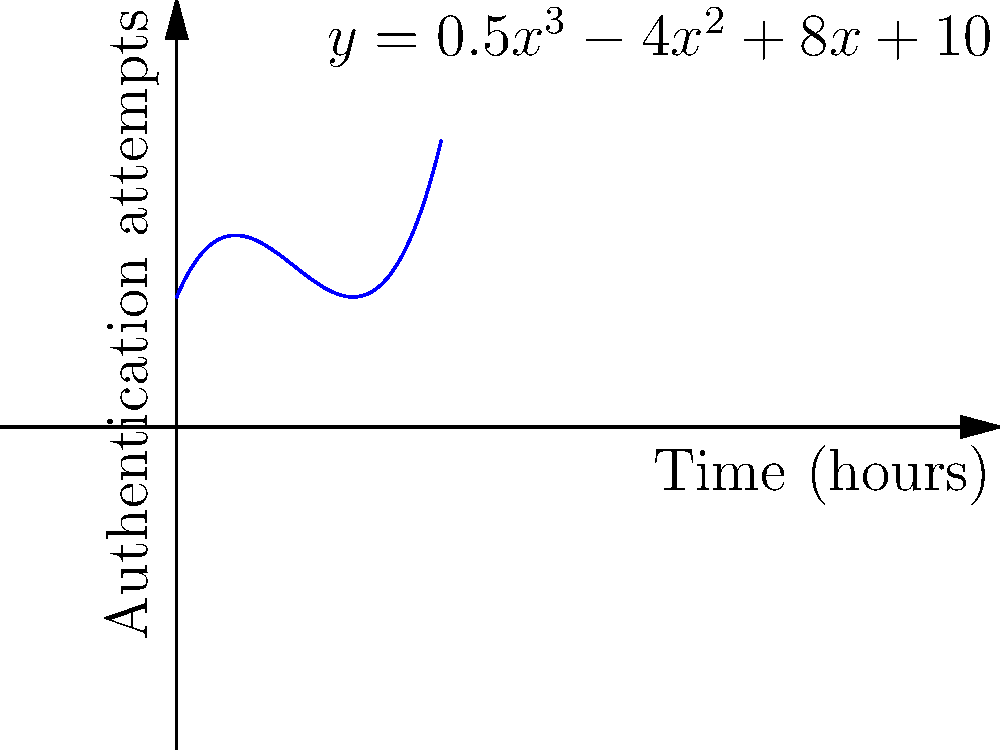The graph shows the number of user authentication attempts over time for a secure data management system. The polynomial function modeling this behavior is given by $y = 0.5x^3 - 4x^2 + 8x + 10$, where $x$ is time in hours and $y$ is the number of authentication attempts. At what time does the system experience a local minimum number of authentication attempts? To find the local minimum, we need to follow these steps:

1) The local minimum occurs where the derivative of the function is zero and the second derivative is positive.

2) First, let's find the derivative:
   $f'(x) = 1.5x^2 - 8x + 8$

3) Set the derivative to zero and solve:
   $1.5x^2 - 8x + 8 = 0$
   
4) This is a quadratic equation. We can solve it using the quadratic formula:
   $x = \frac{-b \pm \sqrt{b^2 - 4ac}}{2a}$
   
   Where $a = 1.5$, $b = -8$, and $c = 8$

5) Plugging in these values:
   $x = \frac{8 \pm \sqrt{64 - 48}}{3} = \frac{8 \pm 4}{3}$

6) This gives us two solutions:
   $x_1 = \frac{12}{3} = 4$ and $x_2 = \frac{4}{3} \approx 1.33$

7) To determine which one is the minimum, we need to check the second derivative:
   $f''(x) = 3x - 8$

8) At $x = 4$, $f''(4) = 12 - 8 = 4 > 0$, so this is a local minimum.
   At $x = \frac{4}{3}$, $f''(\frac{4}{3}) = 4 - 8 = -4 < 0$, so this is a local maximum.

Therefore, the local minimum occurs at $x = 4$ hours.
Answer: 4 hours 